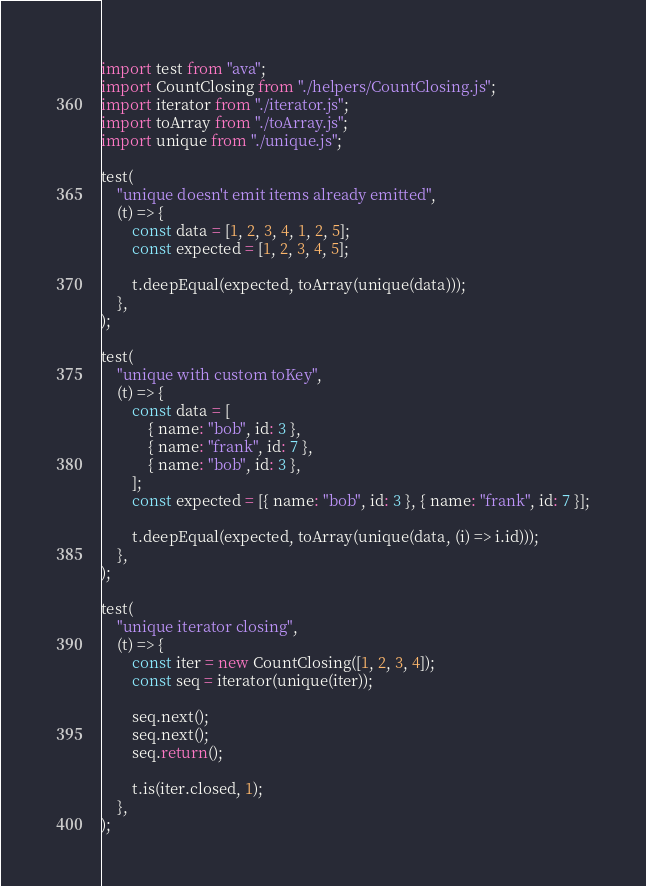<code> <loc_0><loc_0><loc_500><loc_500><_TypeScript_>import test from "ava";
import CountClosing from "./helpers/CountClosing.js";
import iterator from "./iterator.js";
import toArray from "./toArray.js";
import unique from "./unique.js";

test(
    "unique doesn't emit items already emitted",
    (t) => {
        const data = [1, 2, 3, 4, 1, 2, 5];
        const expected = [1, 2, 3, 4, 5];

        t.deepEqual(expected, toArray(unique(data)));
    },
);

test(
    "unique with custom toKey",
    (t) => {
        const data = [
            { name: "bob", id: 3 },
            { name: "frank", id: 7 },
            { name: "bob", id: 3 },
        ];
        const expected = [{ name: "bob", id: 3 }, { name: "frank", id: 7 }];

        t.deepEqual(expected, toArray(unique(data, (i) => i.id)));
    },
);

test(
    "unique iterator closing",
    (t) => {
        const iter = new CountClosing([1, 2, 3, 4]);
        const seq = iterator(unique(iter));

        seq.next();
        seq.next();
        seq.return();

        t.is(iter.closed, 1);
    },
);
</code> 